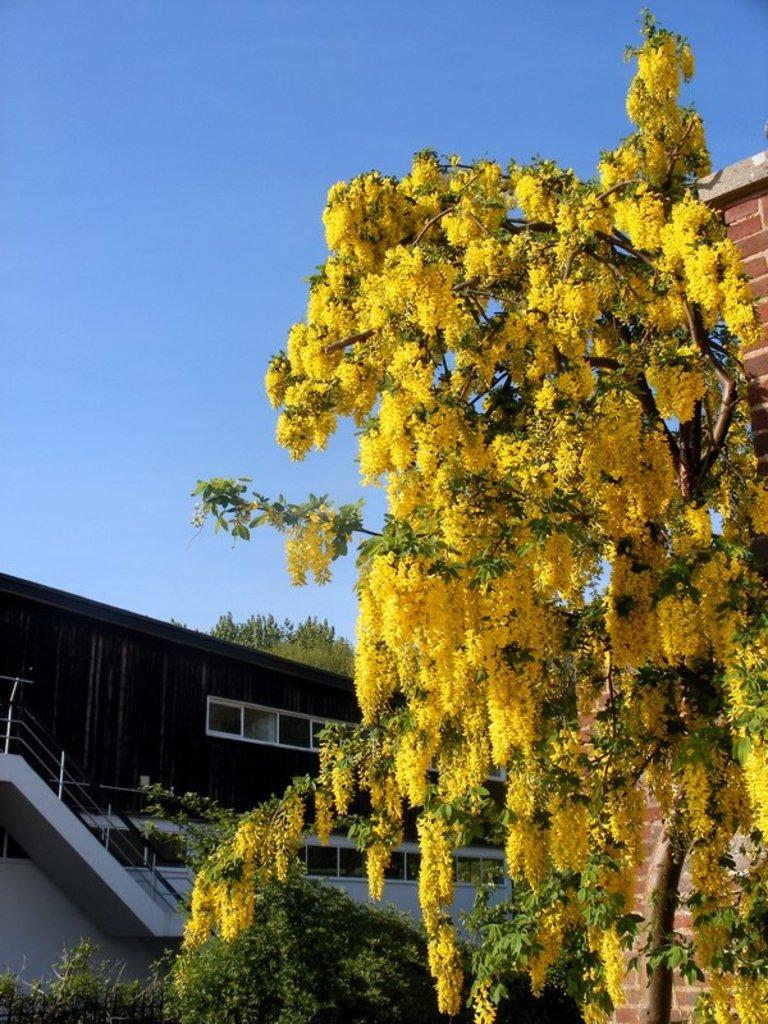What type of structures are visible in the image? There are buildings in the image. What other natural elements can be seen in the image? There are trees in the image. What color is the sky in the image? The sky is blue in the image. What type of brush is being used to clean the sink in the image? There is no sink or brush present in the image; it only features buildings, trees, and a blue sky. 